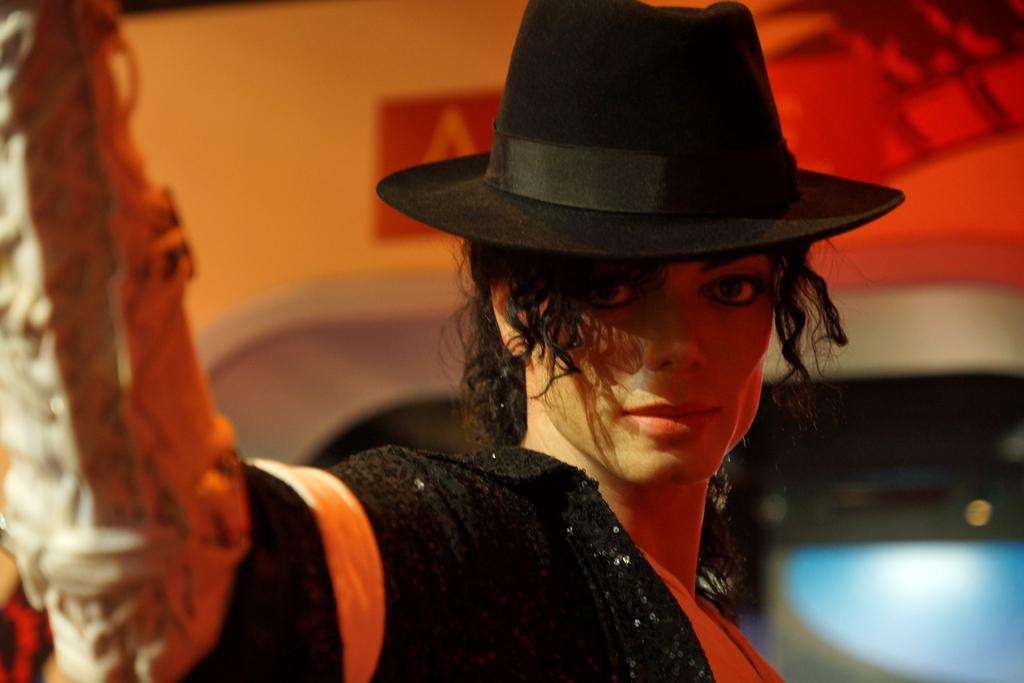Who is the person in the image? Michael Jackson is in the image. What is Michael Jackson doing in the image? Michael Jackson is posing for a picture. What accessory is Michael Jackson wearing in the image? Michael Jackson is wearing a hat. What can be seen behind Michael Jackson in the image? There is a wall behind Michael Jackson. What type of curve can be seen in the image? There is no curve present in the image. Is Michael Jackson taking a selfie in the image? The image does not show Michael Jackson taking a selfie; he is posing for a picture. 